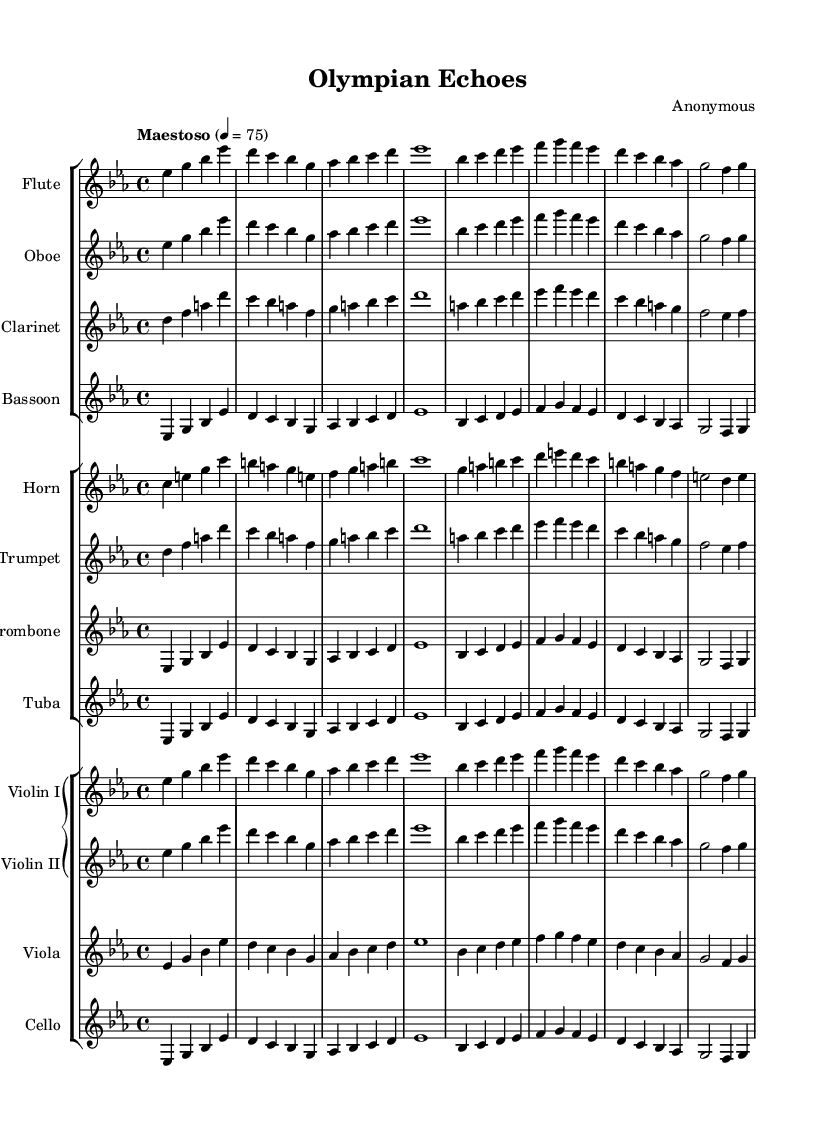what is the key signature of this music? The key signature indicates that there are three flats in the music, which is characteristic of E-flat major or C minor. Here, it is E-flat major, as inferred from the overall tonality of the piece.
Answer: E-flat major what is the time signature of this music? The time signature shown at the beginning of the music indicates that there are four beats in each measure, represented by "4/4". This means it is a common time signature.
Answer: 4/4 what is the tempo marking for this piece? The tempo marking indicates that the piece should be played at a "Maestoso" pace, which suggests a grand and stately performance style, typically at a speed of 75 beats per minute.
Answer: Maestoso how many measures are in the flute part? By counting the measures in the flute part from the start to the end, we can see there are six measures total, as indicated by the grouping of notes.
Answer: 6 which instruments are included in the woodwind section? The woodwind section listed in the score features four instruments: flute, oboe, clarinet, and bassoon. This can be confirmed by examining the staff groups for string distribution in the layout.
Answer: Flute, Oboe, Clarinet, Bassoon which instruments are transposed in this score? The instruments that require transposition in this score are the clarinet in B-flat, the horn in F, and the trumpet in B-flat. Their respective transposition information is indicated at the beginning of their respective staffs.
Answer: Clarinet, Horn, Trumpet what is the overall mood suggested by the tempo and key signature? The combination of E-flat major, typically associated with a warm and heroic character, along with the Maestoso tempo, conveys a grand and majestic mood throughout the piece, fitting for symphonic poems celebrating European landscapes and historical landmarks.
Answer: Grand and majestic 